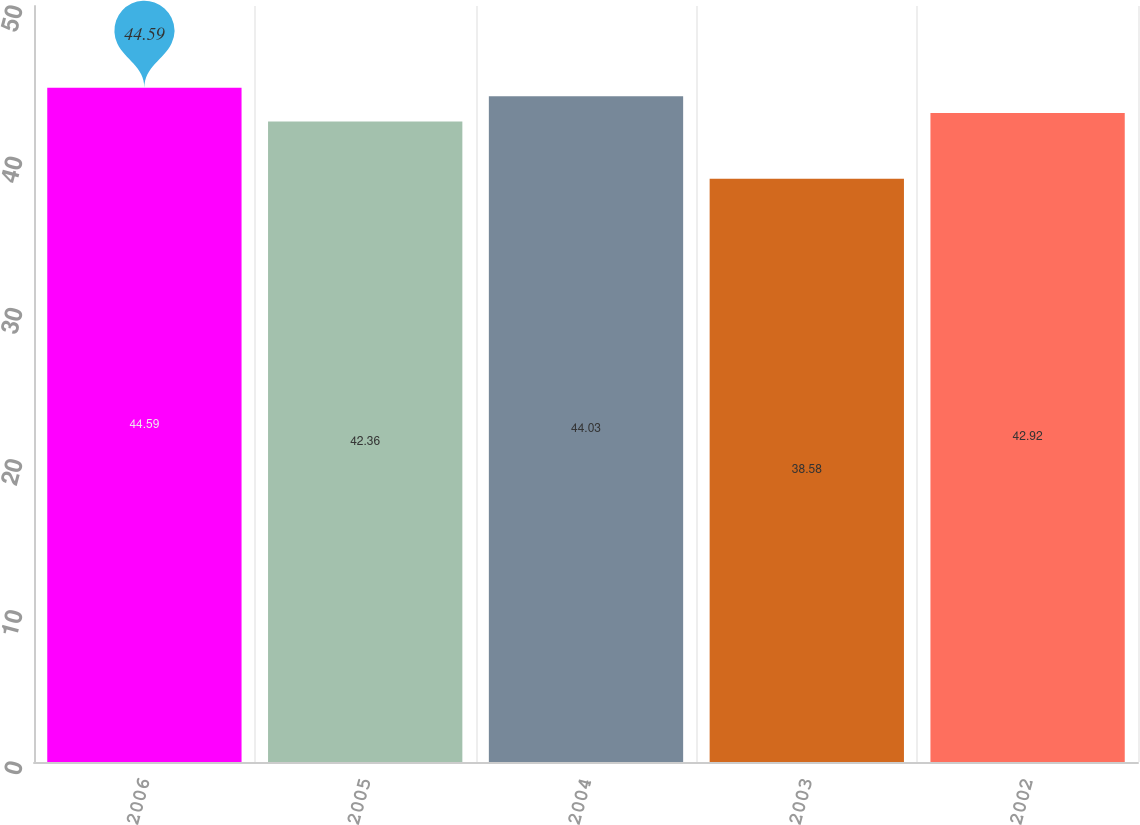<chart> <loc_0><loc_0><loc_500><loc_500><bar_chart><fcel>2006<fcel>2005<fcel>2004<fcel>2003<fcel>2002<nl><fcel>44.59<fcel>42.36<fcel>44.03<fcel>38.58<fcel>42.92<nl></chart> 